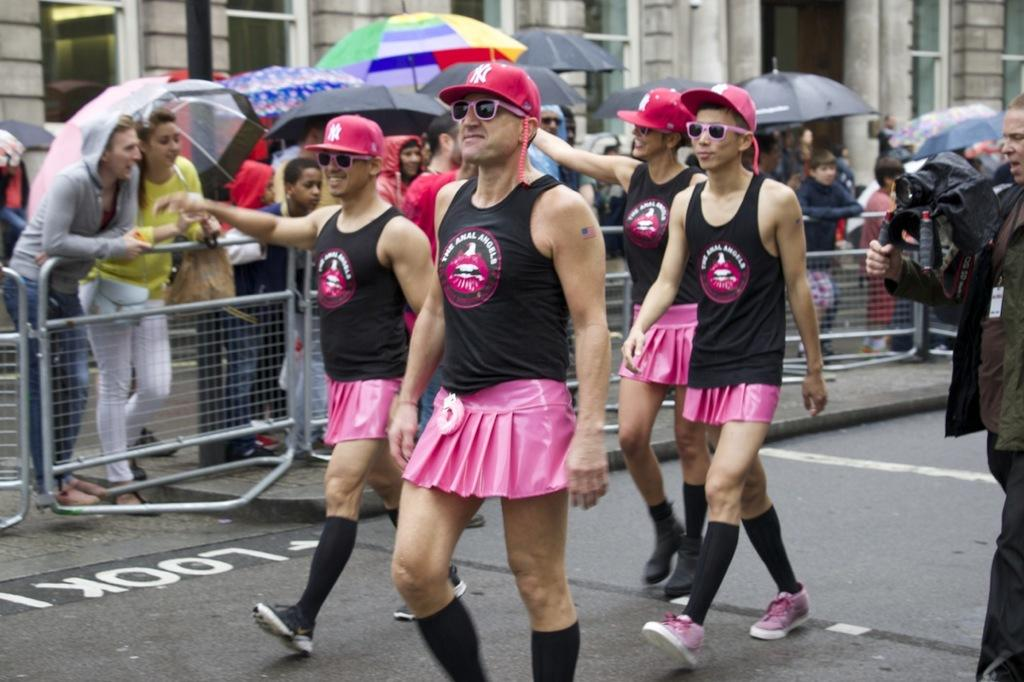What are the people in the image doing? There are people walking on the road in the image. Are there any obstacles or barriers present in the image? Yes, there are barricades present in the image. What are the people holding while walking or standing? The people are holding umbrellas in the image. What can be seen in the background of the image? There is a building visible in the image. What type of thrill game are the people playing in the image? There is no game or thrill activity present in the image; the people are walking and holding umbrellas. Can you tell me how many servants are visible in the image? There are no servants present in the image. 